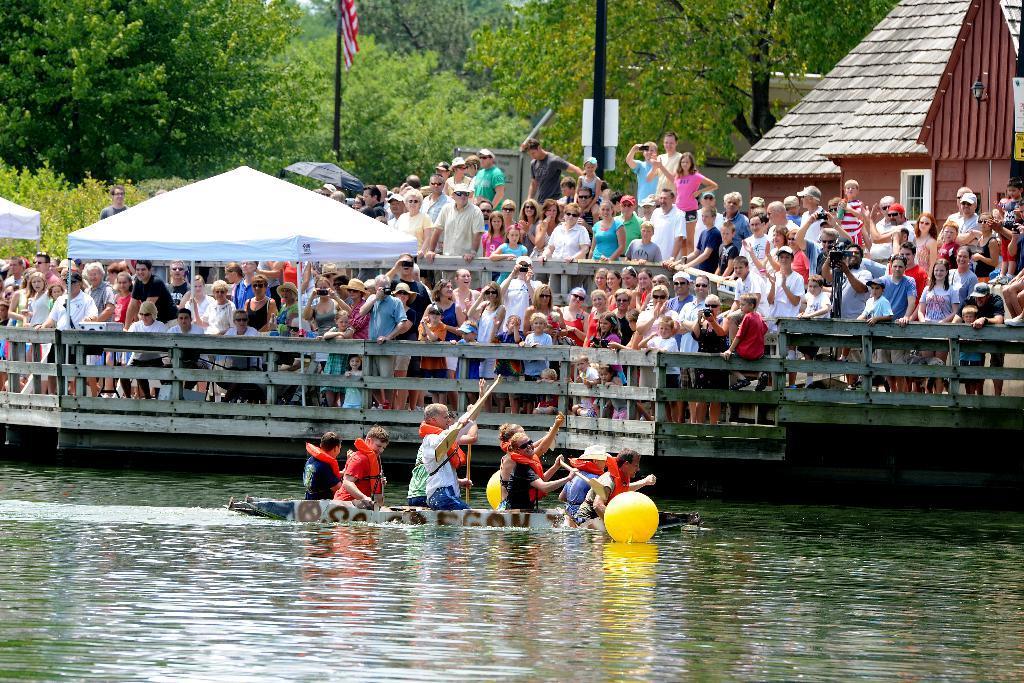Can you describe this image briefly? In this image I can see few people on the boat and I can see the boat and the yellow color ball on the water. In the background I can see the railing, tents and many people with different color dresses. I can see the buildings, flag, boards, many trees and the sky. 